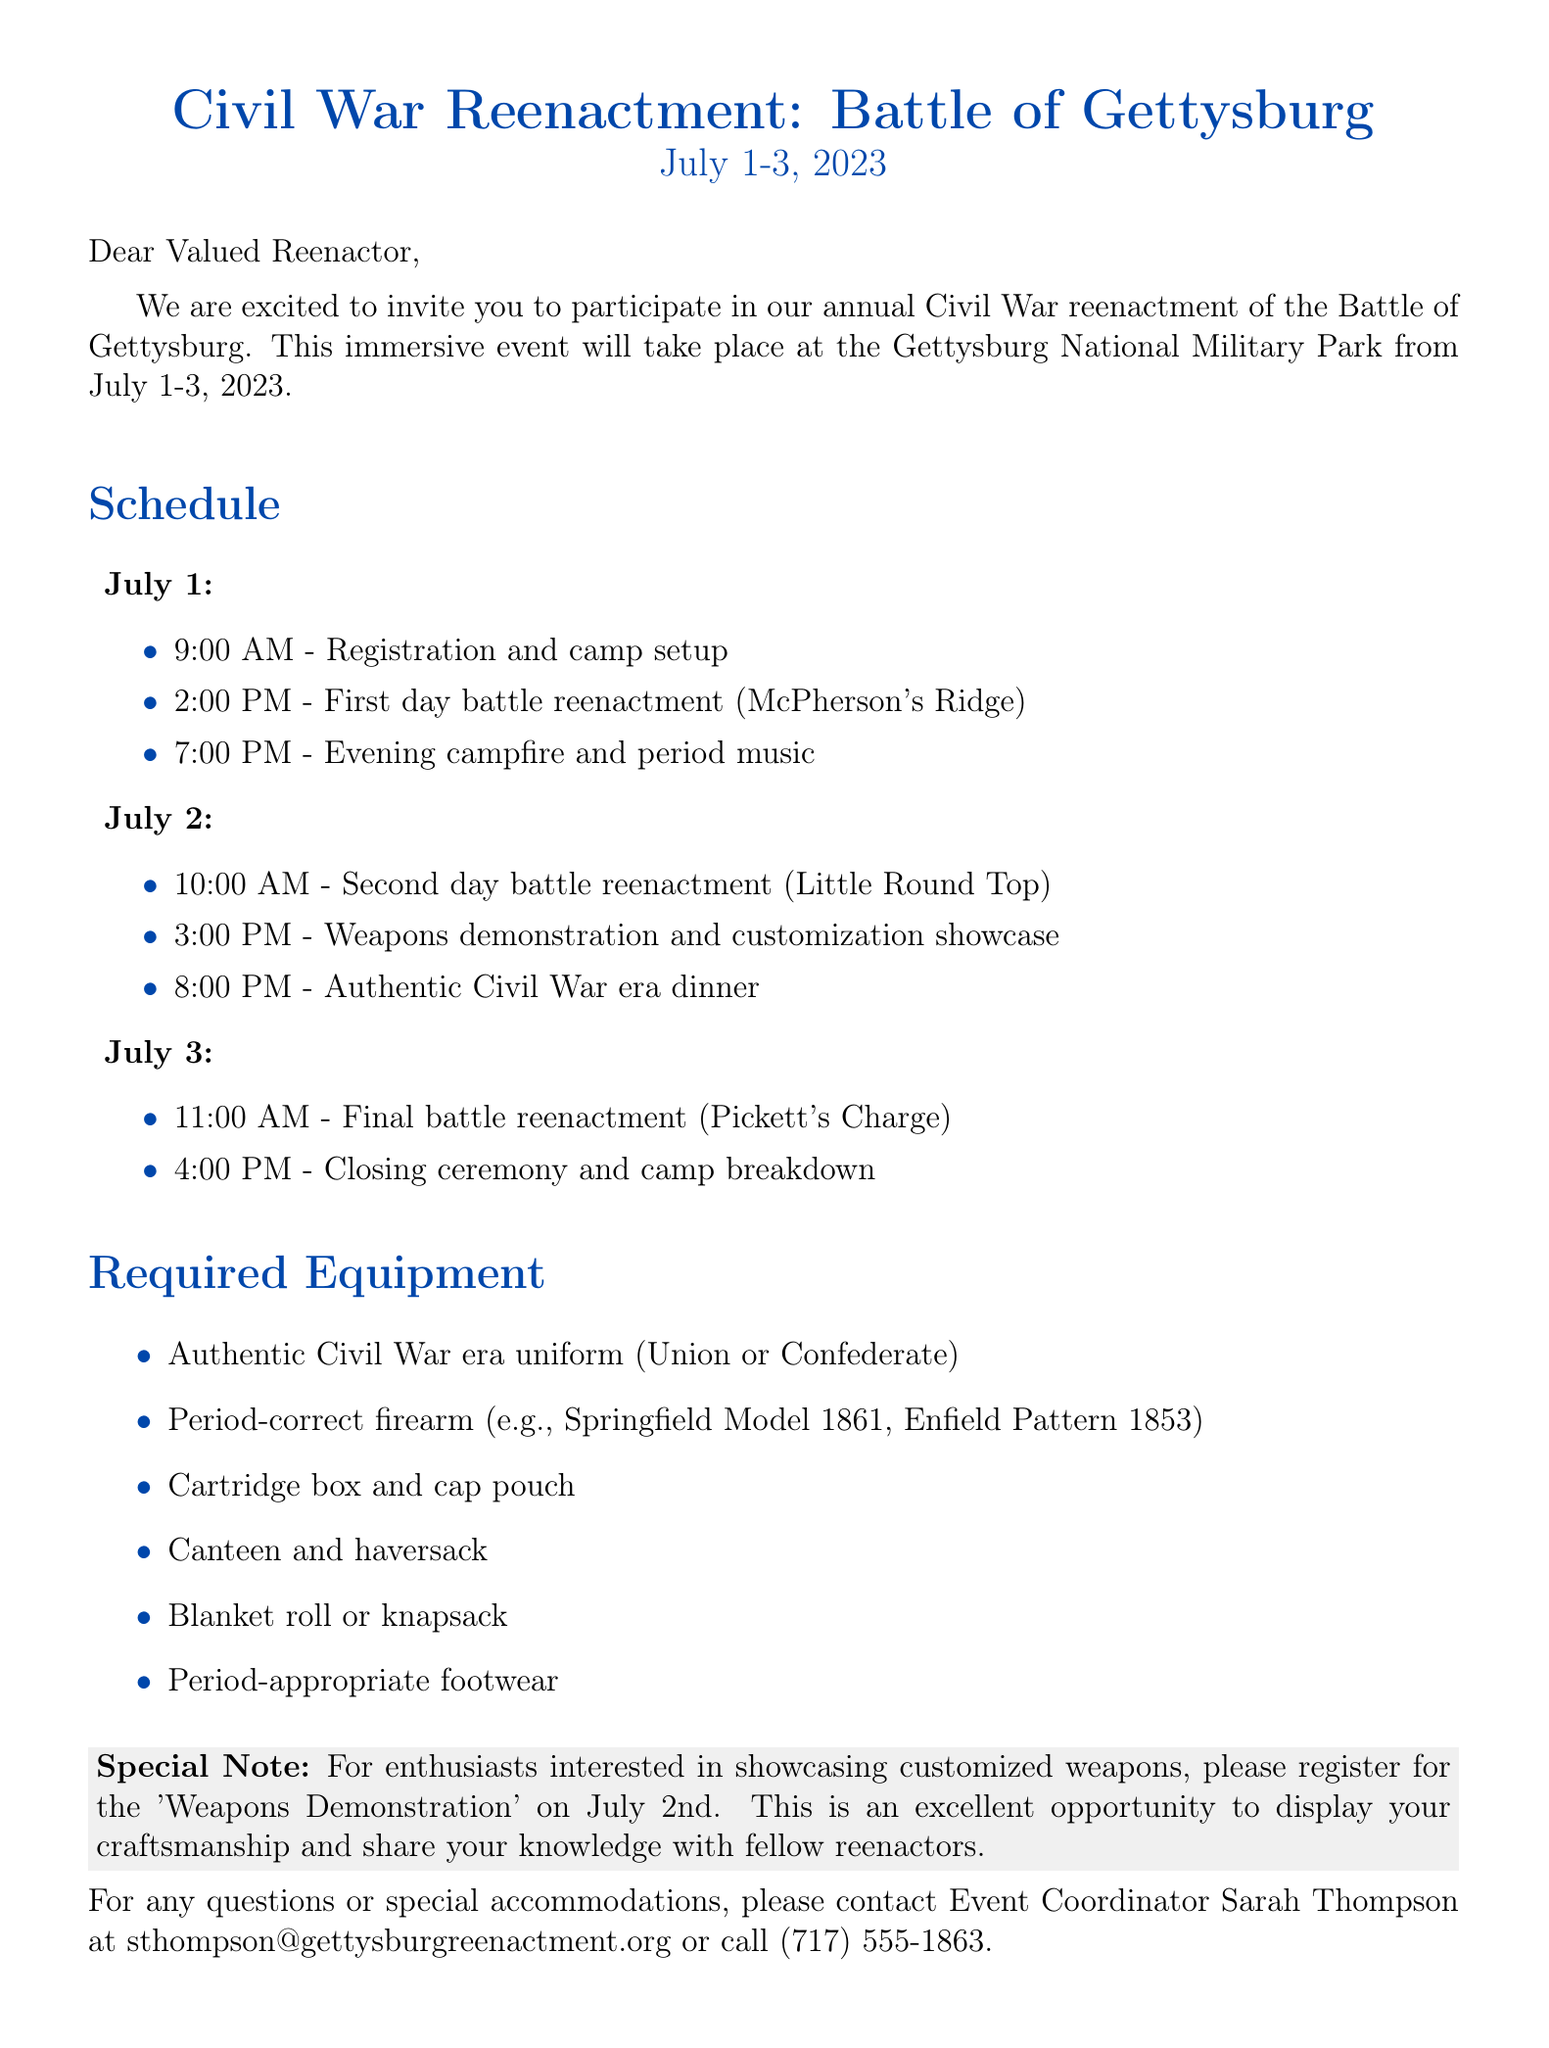What are the dates of the event? The dates of the event are explicitly stated as July 1-3, 2023.
Answer: July 1-3, 2023 Who should be contacted for questions? The document specifies Sarah Thompson as the contact for any questions or special accommodations.
Answer: Sarah Thompson What equipment is required for the event? The document lists several items that are required, including a uniform, firearm, and accessories.
Answer: Authentic Civil War era uniform (Union or Confederate) What time does the weapons demonstration take place? The schedule indicates that the weapons demonstration is scheduled for 3:00 PM on July 2.
Answer: 3:00 PM What is the focus of the special note in the document? The special note invites enthusiasts to showcase customized weapons during the event.
Answer: Showcasing customized weapons How many battle reenactments are scheduled? The document outlines three battle reenactments occurring over the event's three days.
Answer: Three 